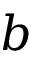Convert formula to latex. <formula><loc_0><loc_0><loc_500><loc_500>b</formula> 